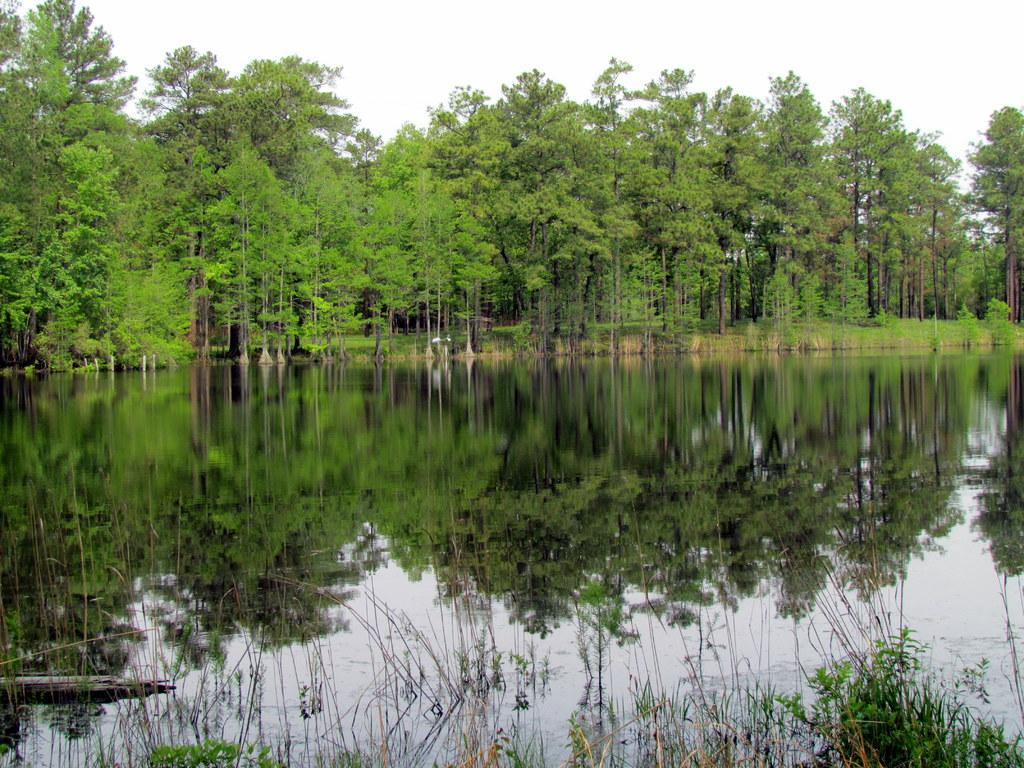What type of vegetation can be seen in the image? There are trees in the image. What natural element is visible in the image besides the trees? There is water visible in the image. How would you describe the sky in the image? The sky appears to be cloudy in the image. Where is the kitty hiding in the image? There is no kitty present in the image. 